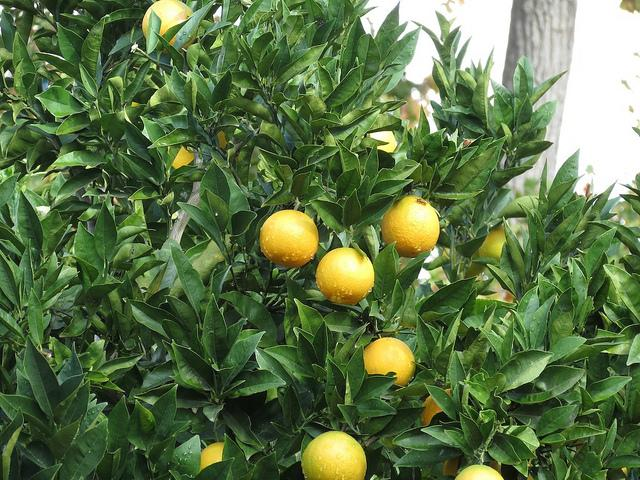What type of fruit is most likely on the tree? Please explain your reasoning. lemon. These are lemons. 